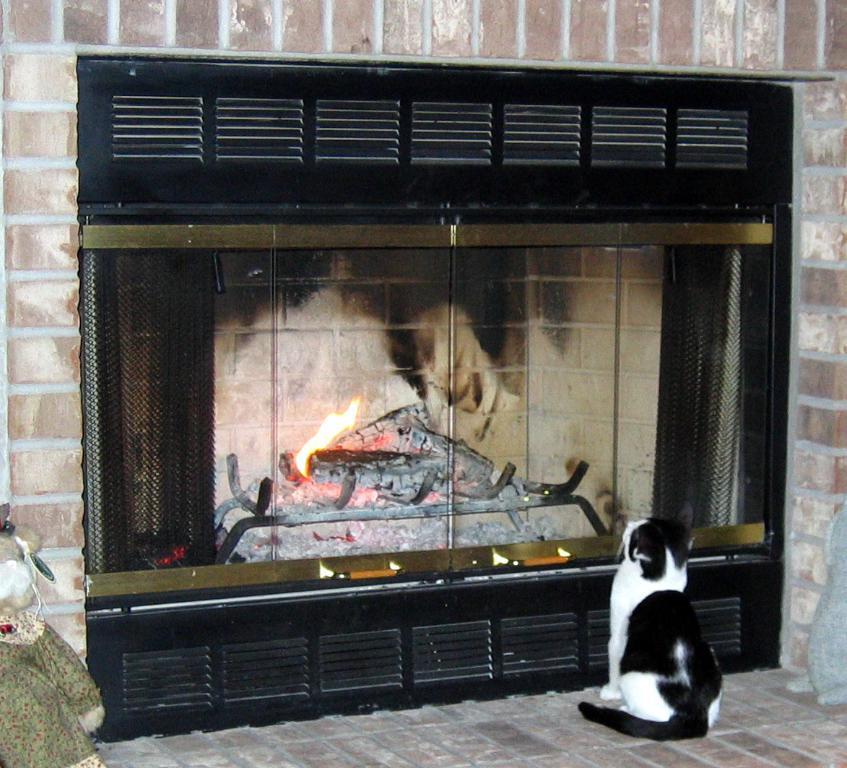Can you describe this image briefly? In this picture we can see a cat in front of the fireplace. 